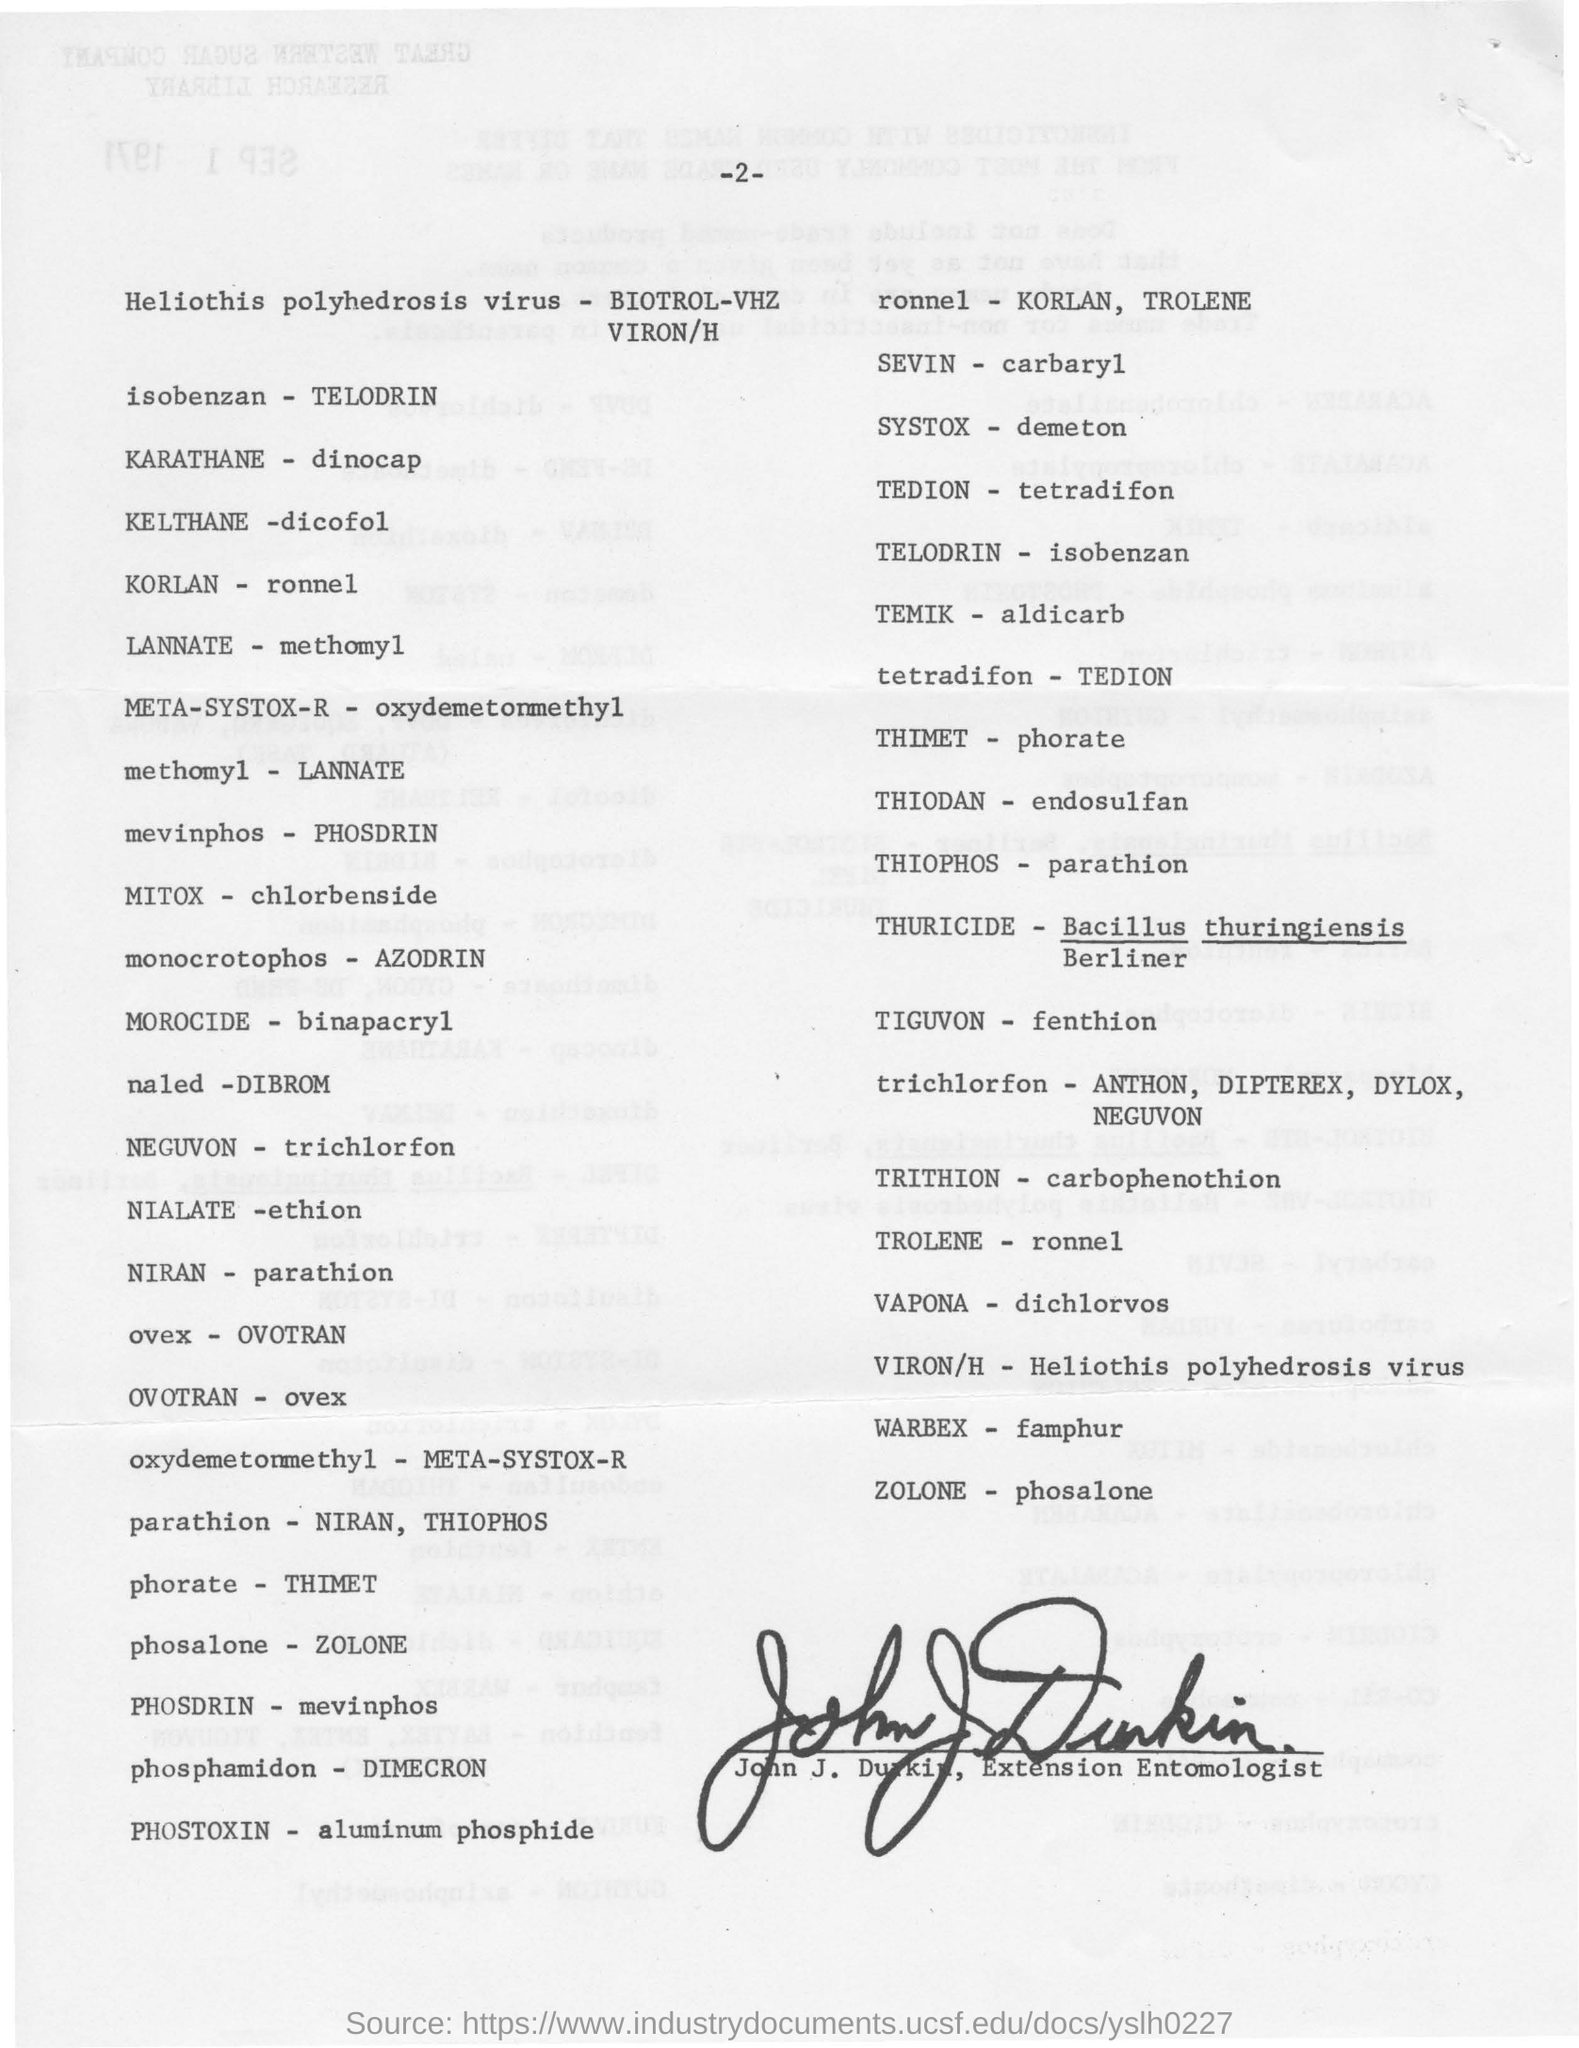Whose signature is present at the bottom?
Provide a succinct answer. John J. Durkin. What word is mentioned to the opposite of ZOLONE?
Ensure brevity in your answer.  Phosalone. What is opposite to trichlorfon?
Your response must be concise. Neguvon. What word is opposite to KORLAN, TROLENE?
Provide a short and direct response. Ronnel. 